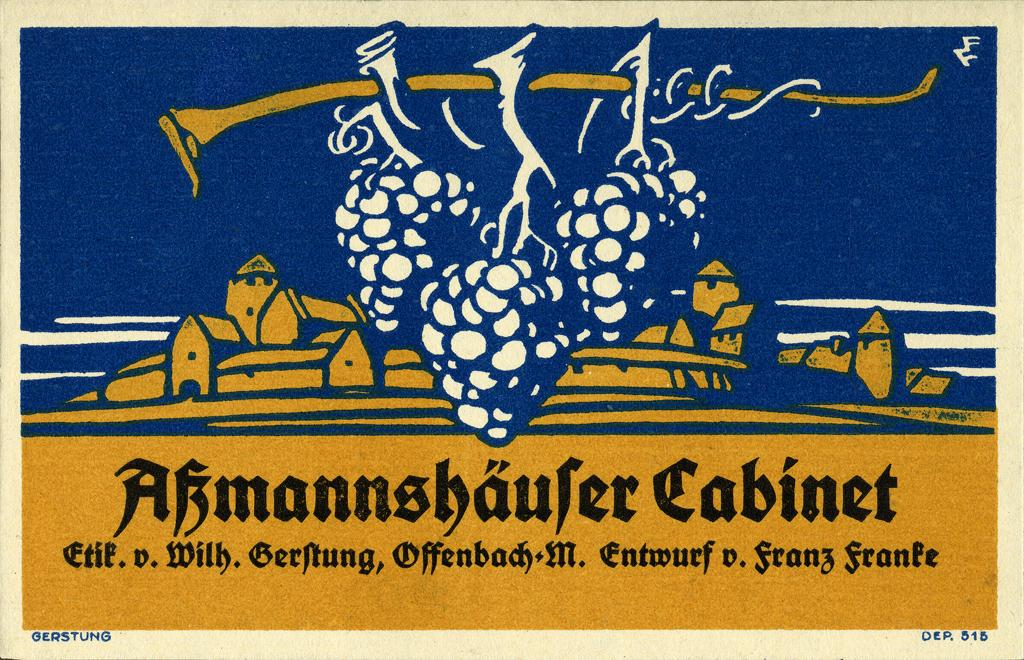<image>
Render a clear and concise summary of the photo. An image of grapes on the vine has the word "Cabinet" on it. 